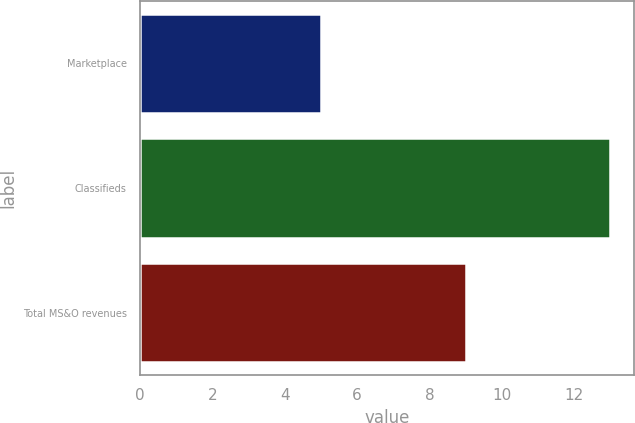Convert chart. <chart><loc_0><loc_0><loc_500><loc_500><bar_chart><fcel>Marketplace<fcel>Classifieds<fcel>Total MS&O revenues<nl><fcel>5<fcel>13<fcel>9<nl></chart> 